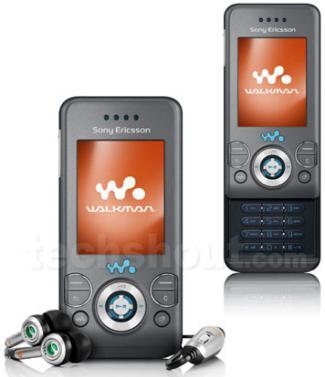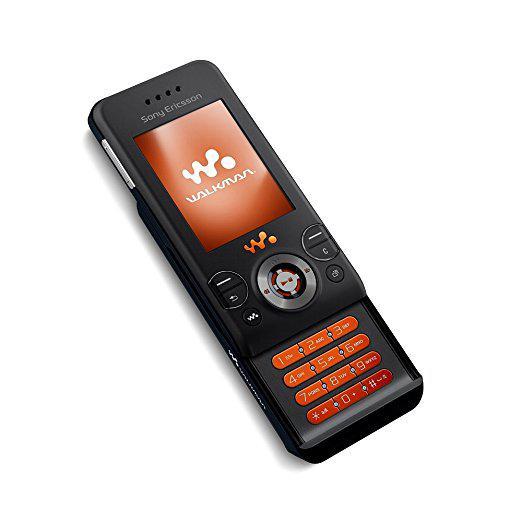The first image is the image on the left, the second image is the image on the right. For the images shown, is this caption "Each image contains one device, each device has a vertical rectangular screen, and one device is shown with its front sliding up to reveal the key pad." true? Answer yes or no. No. The first image is the image on the left, the second image is the image on the right. For the images shown, is this caption "The phone in the image on the right is in the slide out position." true? Answer yes or no. Yes. 